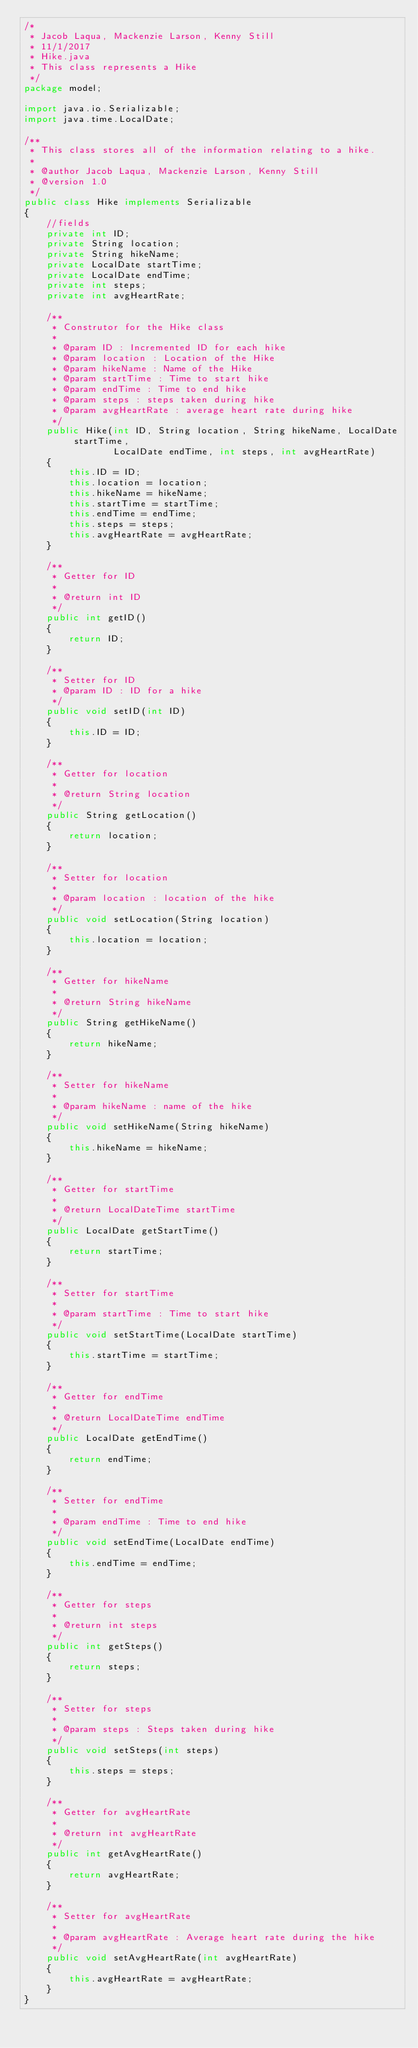Convert code to text. <code><loc_0><loc_0><loc_500><loc_500><_Java_>/*
 * Jacob Laqua, Mackenzie Larson, Kenny Still
 * 11/1/2017
 * Hike.java
 * This class represents a Hike
 */
package model;

import java.io.Serializable;
import java.time.LocalDate;

/**
 * This class stores all of the information relating to a hike.
 *
 * @author Jacob Laqua, Mackenzie Larson, Kenny Still
 * @version 1.0
 */
public class Hike implements Serializable
{
    //fields
    private int ID;
    private String location;
    private String hikeName;
    private LocalDate startTime;
    private LocalDate endTime;
    private int steps;
    private int avgHeartRate;

    /**
     * Construtor for the Hike class
     *
     * @param ID : Incremented ID for each hike
     * @param location : Location of the Hike
     * @param hikeName : Name of the Hike
     * @param startTime : Time to start hike
     * @param endTime : Time to end hike
     * @param steps : steps taken during hike
     * @param avgHeartRate : average heart rate during hike
     */
    public Hike(int ID, String location, String hikeName, LocalDate startTime,
                LocalDate endTime, int steps, int avgHeartRate)
    {
        this.ID = ID;
        this.location = location;
        this.hikeName = hikeName;
        this.startTime = startTime;
        this.endTime = endTime;
        this.steps = steps;
        this.avgHeartRate = avgHeartRate;
    }

    /**
     * Getter for ID
     *
     * @return int ID
     */
    public int getID()
    {
        return ID;
    }

    /**
     * Setter for ID
     * @param ID : ID for a hike
     */
    public void setID(int ID)
    {
        this.ID = ID;
    }

    /**
     * Getter for location
     *
     * @return String location
     */
    public String getLocation()
    {
        return location;
    }

    /**
     * Setter for location
     *
     * @param location : location of the hike
     */
    public void setLocation(String location)
    {
        this.location = location;
    }

    /**
     * Getter for hikeName
     *
     * @return String hikeName
     */
    public String getHikeName()
    {
        return hikeName;
    }

    /**
     * Setter for hikeName
     *
     * @param hikeName : name of the hike
     */
    public void setHikeName(String hikeName)
    {
        this.hikeName = hikeName;
    }

    /**
     * Getter for startTime
     *
     * @return LocalDateTime startTime
     */
    public LocalDate getStartTime()
    {
        return startTime;
    }

    /**
     * Setter for startTime
     *
     * @param startTime : Time to start hike
     */
    public void setStartTime(LocalDate startTime)
    {
        this.startTime = startTime;
    }

    /**
     * Getter for endTime
     *
     * @return LocalDateTime endTime
     */
    public LocalDate getEndTime()
    {
        return endTime;
    }

    /**
     * Setter for endTime
     *
     * @param endTime : Time to end hike
     */
    public void setEndTime(LocalDate endTime)
    {
        this.endTime = endTime;
    }

    /**
     * Getter for steps
     *
     * @return int steps
     */
    public int getSteps()
    {
        return steps;
    }

    /**
     * Setter for steps
     *
     * @param steps : Steps taken during hike
     */
    public void setSteps(int steps)
    {
        this.steps = steps;
    }

    /**
     * Getter for avgHeartRate
     *
     * @return int avgHeartRate
     */
    public int getAvgHeartRate()
    {
        return avgHeartRate;
    }

    /**
     * Setter for avgHeartRate
     *
     * @param avgHeartRate : Average heart rate during the hike
     */
    public void setAvgHeartRate(int avgHeartRate)
    {
        this.avgHeartRate = avgHeartRate;
    }
}
</code> 